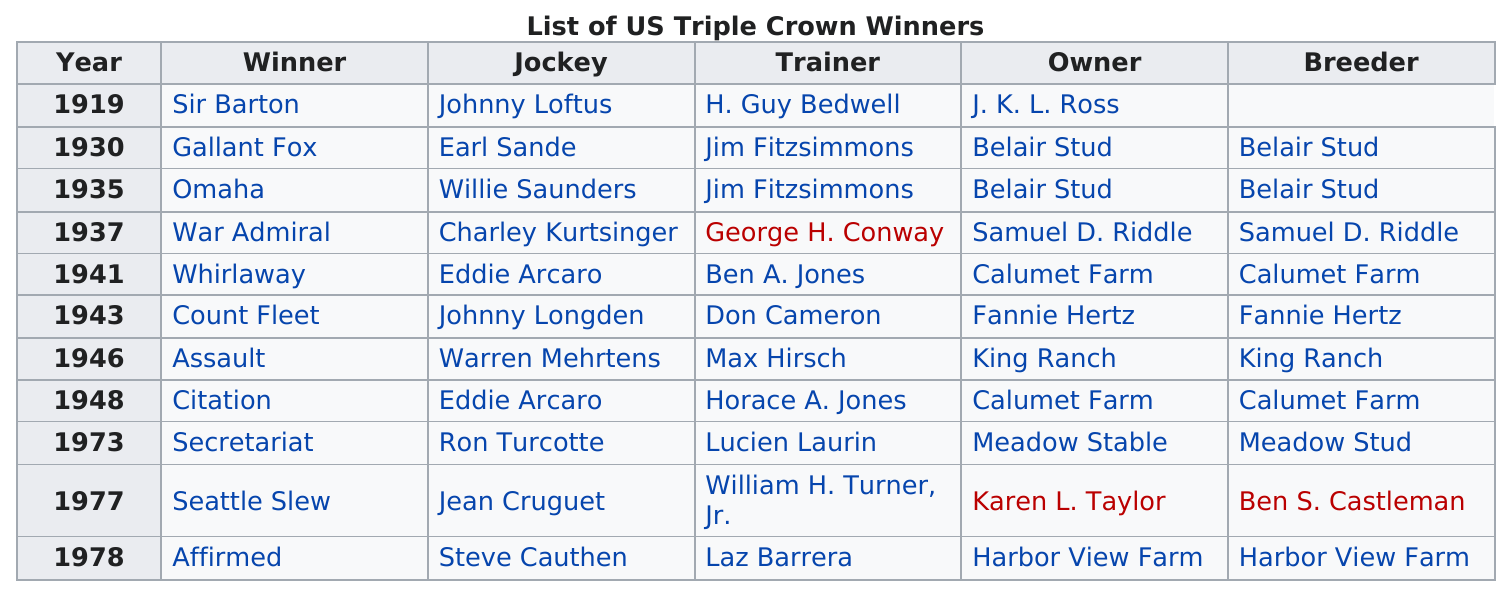Mention a couple of crucial points in this snapshot. Ron Turcotte rode Secretariat in 1973. In the year 1919, there was a Triple Crown winner for the first time in history. The 1941 Triple Crown winner was bred by Calumet Farm. In 1978, Steve Cauthen became the youngest jockey to ever win the Triple Crown when he rode Affirmed to victory in all three races of the prestigious event. Seattle Slew won the Triple Crown in the year 1977. 